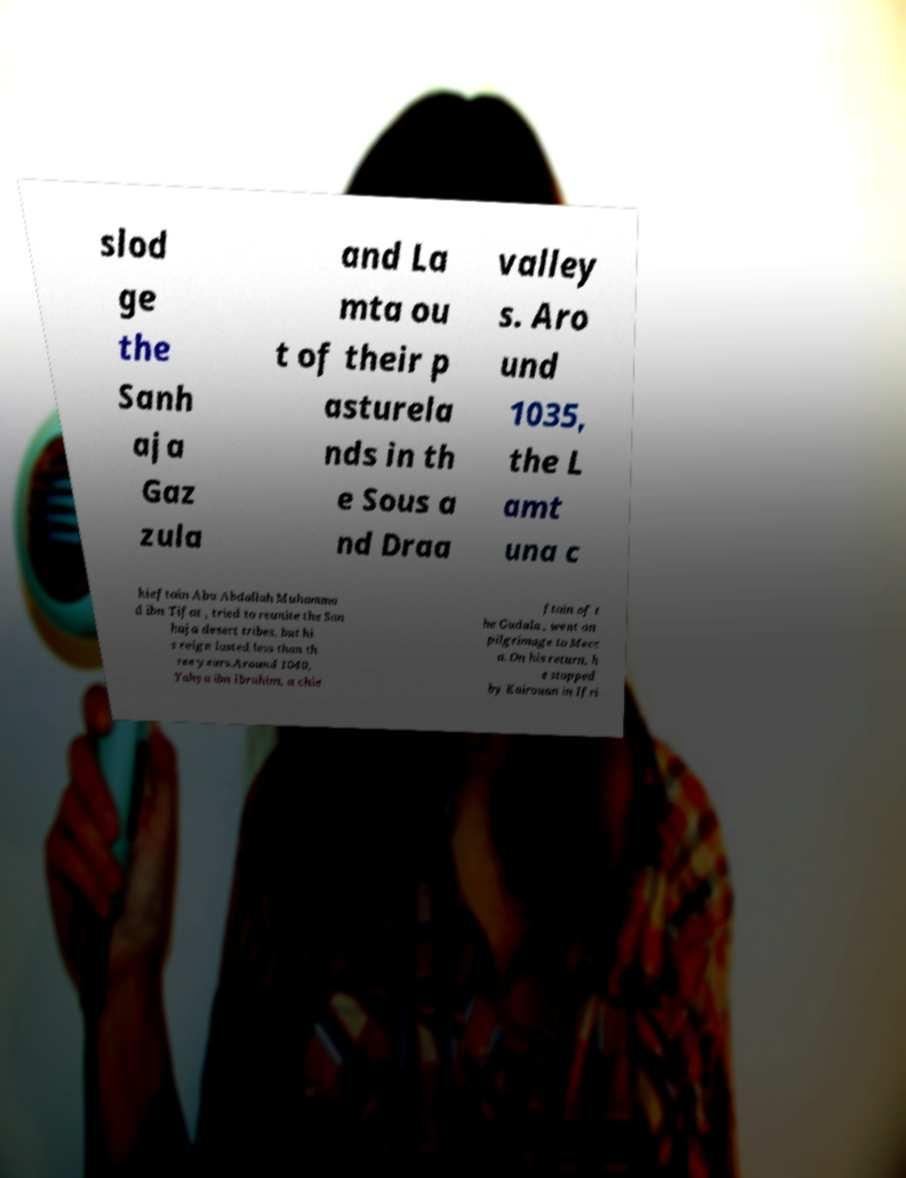Could you extract and type out the text from this image? slod ge the Sanh aja Gaz zula and La mta ou t of their p asturela nds in th e Sous a nd Draa valley s. Aro und 1035, the L amt una c hieftain Abu Abdallah Muhamma d ibn Tifat , tried to reunite the San haja desert tribes, but hi s reign lasted less than th ree years.Around 1040, Yahya ibn Ibrahim, a chie ftain of t he Gudala , went on pilgrimage to Mecc a. On his return, h e stopped by Kairouan in Ifri 